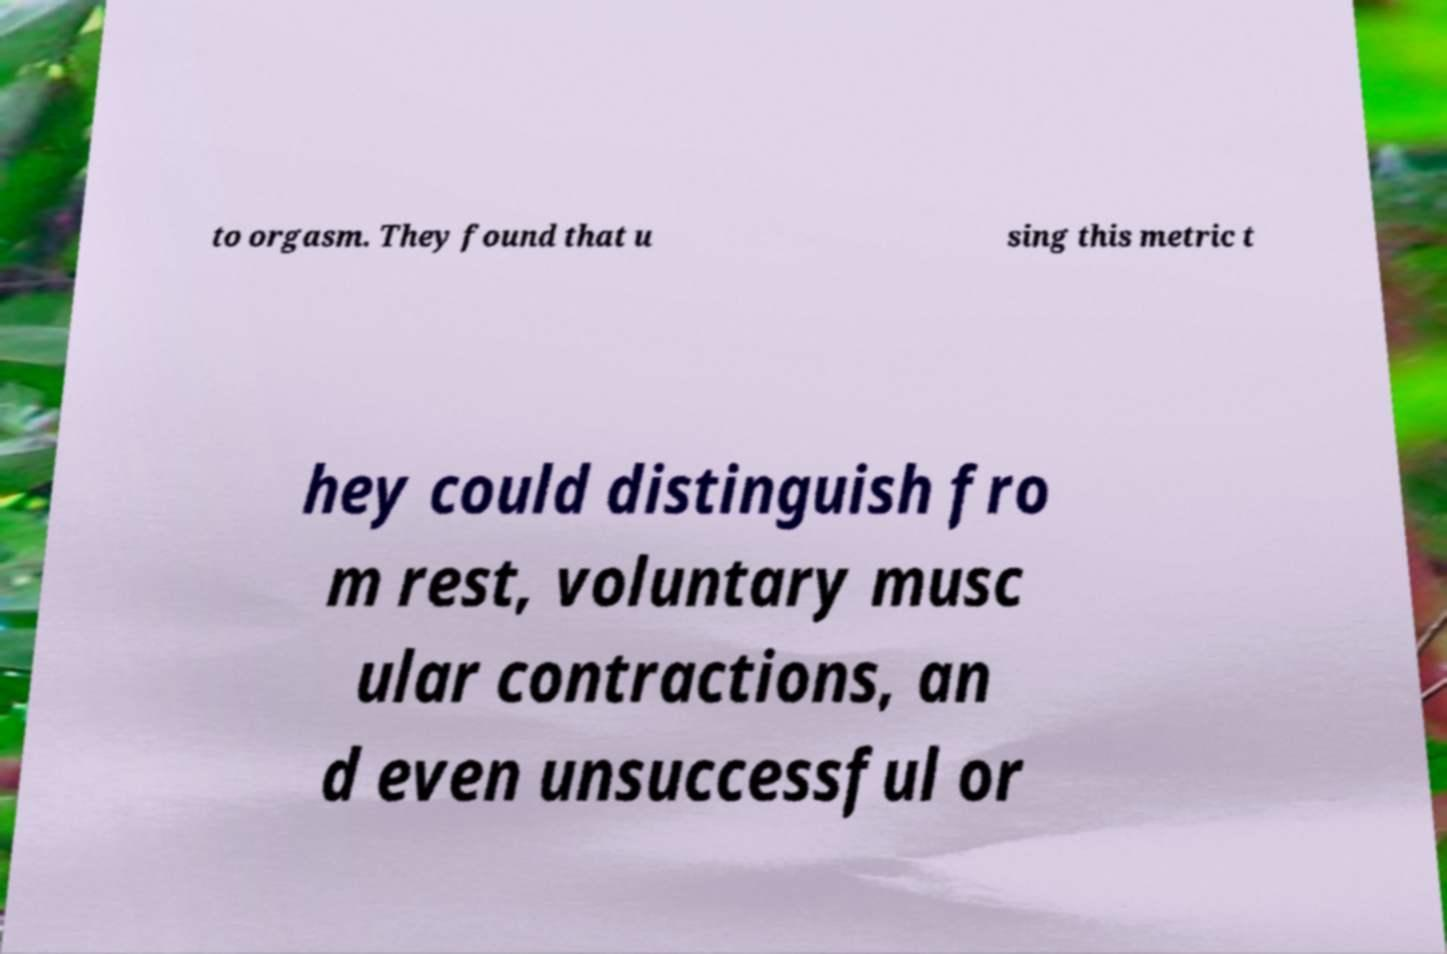Could you assist in decoding the text presented in this image and type it out clearly? to orgasm. They found that u sing this metric t hey could distinguish fro m rest, voluntary musc ular contractions, an d even unsuccessful or 